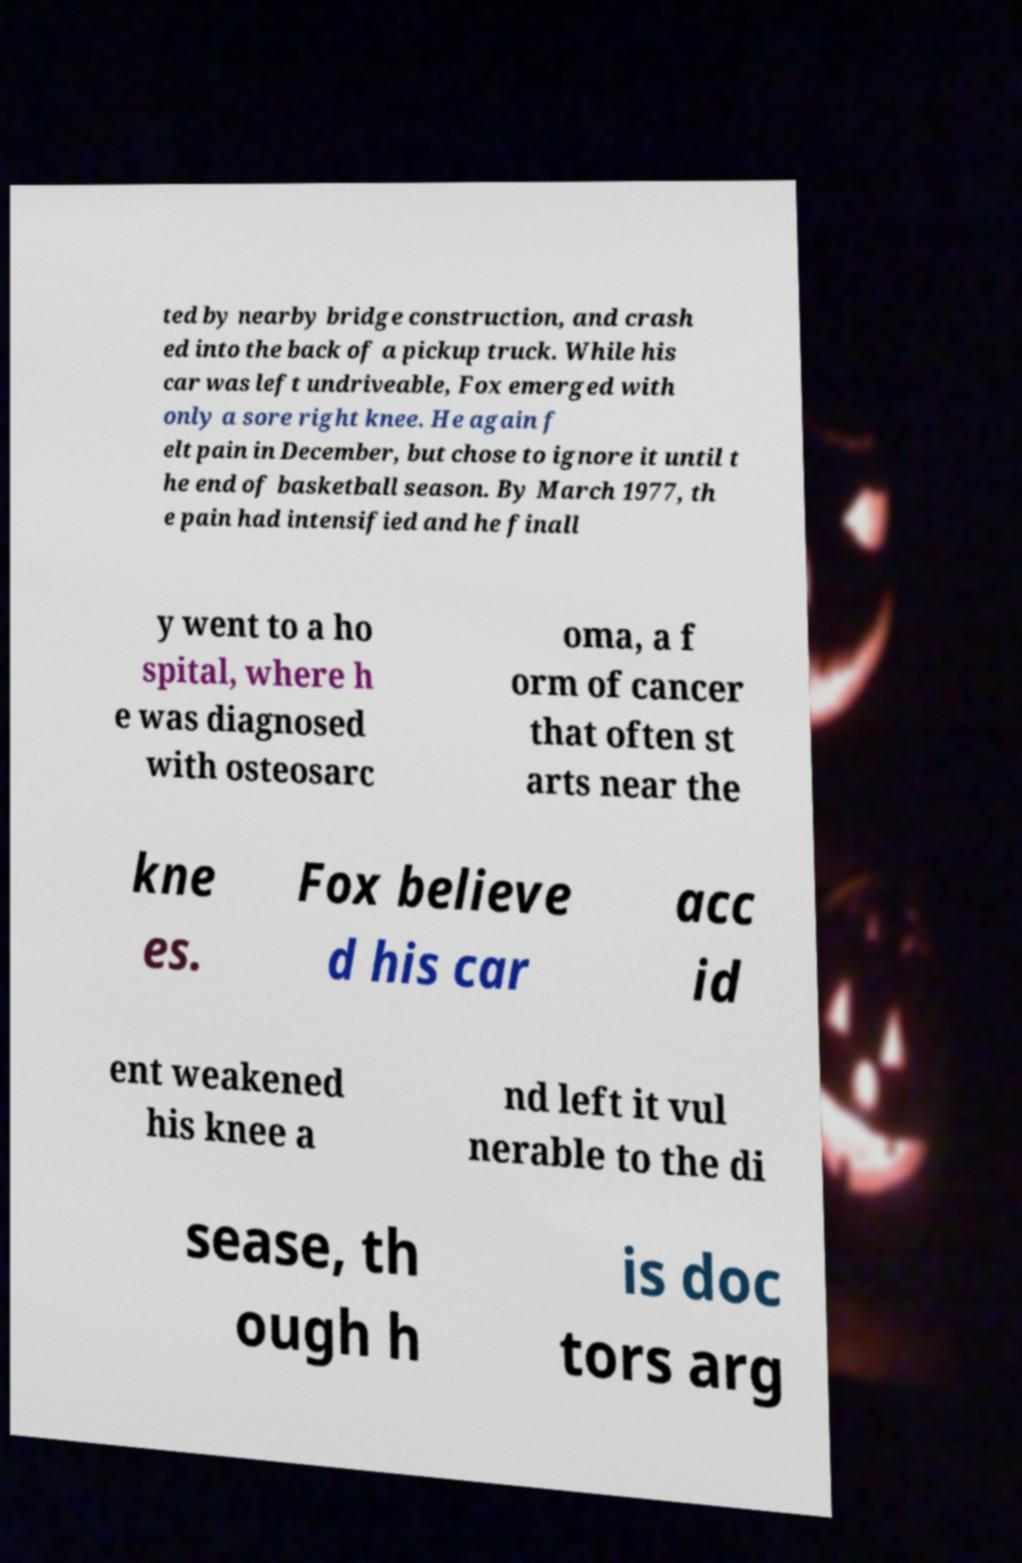I need the written content from this picture converted into text. Can you do that? ted by nearby bridge construction, and crash ed into the back of a pickup truck. While his car was left undriveable, Fox emerged with only a sore right knee. He again f elt pain in December, but chose to ignore it until t he end of basketball season. By March 1977, th e pain had intensified and he finall y went to a ho spital, where h e was diagnosed with osteosarc oma, a f orm of cancer that often st arts near the kne es. Fox believe d his car acc id ent weakened his knee a nd left it vul nerable to the di sease, th ough h is doc tors arg 